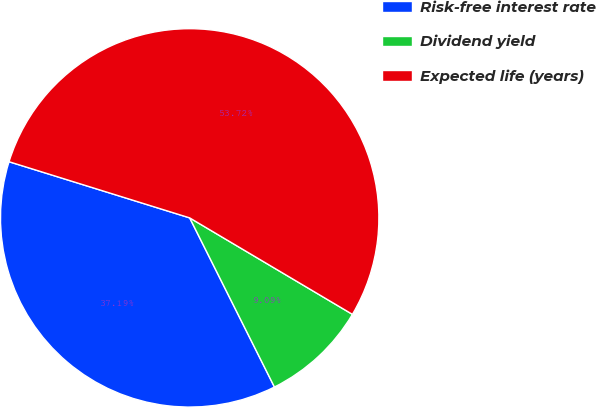Convert chart to OTSL. <chart><loc_0><loc_0><loc_500><loc_500><pie_chart><fcel>Risk-free interest rate<fcel>Dividend yield<fcel>Expected life (years)<nl><fcel>37.19%<fcel>9.09%<fcel>53.72%<nl></chart> 